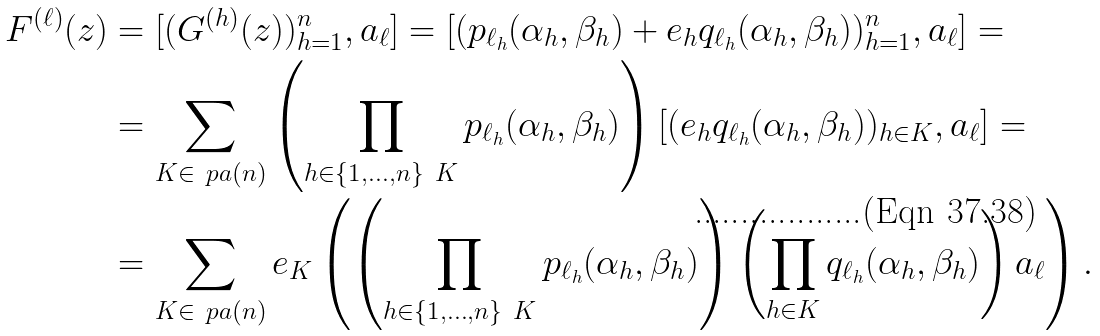<formula> <loc_0><loc_0><loc_500><loc_500>F ^ { ( \ell ) } ( z ) & = [ ( G ^ { ( h ) } ( z ) ) _ { h = 1 } ^ { n } , a _ { \ell } ] = [ ( p _ { \ell _ { h } } ( \alpha _ { h } , \beta _ { h } ) + e _ { h } q _ { \ell _ { h } } ( \alpha _ { h } , \beta _ { h } ) ) _ { h = 1 } ^ { n } , a _ { \ell } ] = \\ & = \sum _ { K \in \ p a ( n ) } \left ( \prod _ { h \in \{ 1 , \dots , n \} \ K } p _ { \ell _ { h } } ( \alpha _ { h } , \beta _ { h } ) \right ) [ ( e _ { h } q _ { \ell _ { h } } ( \alpha _ { h } , \beta _ { h } ) ) _ { h \in K } , a _ { \ell } ] = \\ & = \sum _ { K \in \ p a ( n ) } e _ { K } \left ( \left ( \prod _ { h \in \{ 1 , \dots , n \} \ K } p _ { \ell _ { h } } ( \alpha _ { h } , \beta _ { h } ) \right ) \left ( \prod _ { h \in K } q _ { \ell _ { h } } ( \alpha _ { h } , \beta _ { h } ) \right ) a _ { \ell } \right ) .</formula> 